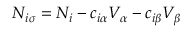Convert formula to latex. <formula><loc_0><loc_0><loc_500><loc_500>N _ { i \sigma } = N _ { i } - c _ { i \alpha } V _ { \alpha } - c _ { i \beta } V _ { \beta }</formula> 